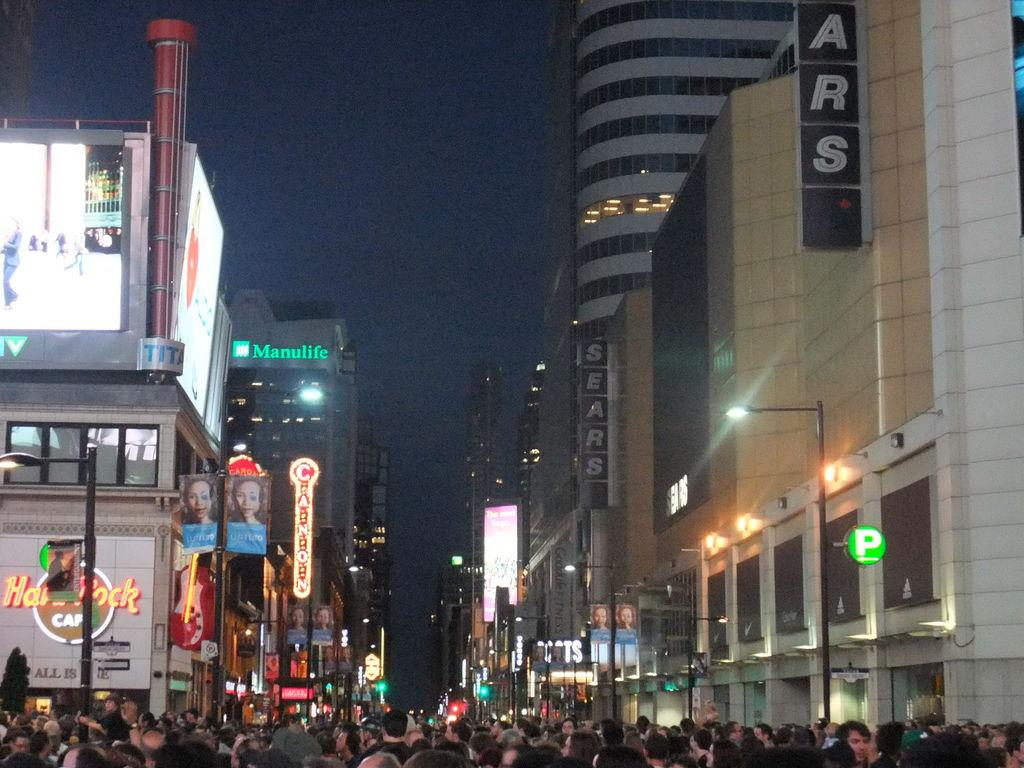<image>
Offer a succinct explanation of the picture presented. A crowd of people are in a city street at night under a building that says Sears. 